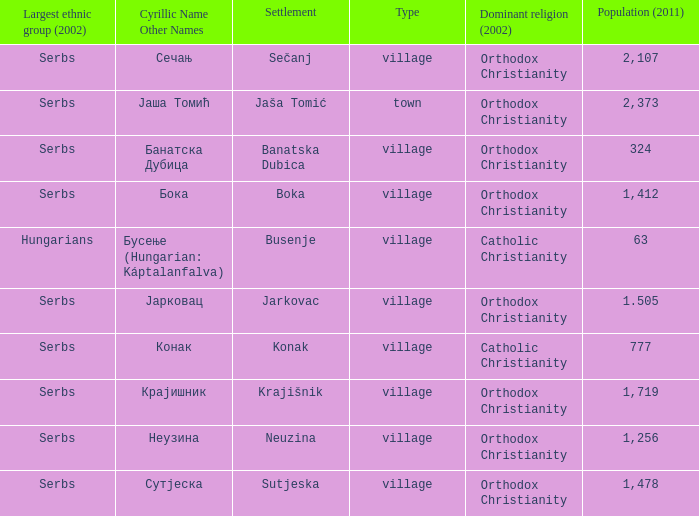The population is 2,107's dominant religion is? Orthodox Christianity. 